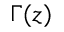<formula> <loc_0><loc_0><loc_500><loc_500>\Gamma ( z )</formula> 